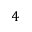<formula> <loc_0><loc_0><loc_500><loc_500>4</formula> 